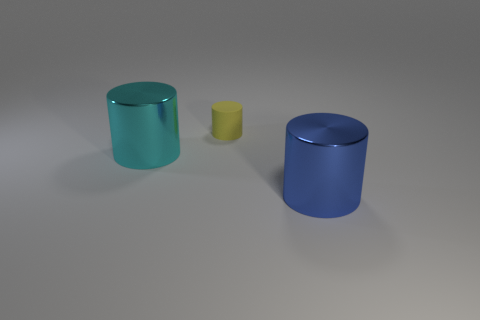There is a thing that is behind the big thing that is to the left of the big blue metal object; what shape is it? cylinder 